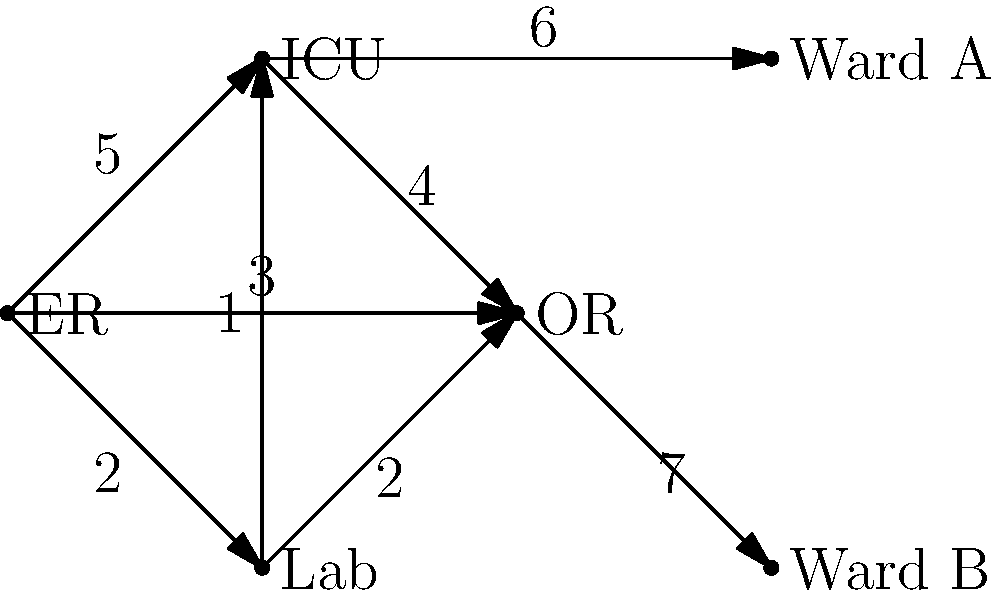Given the hospital department connectivity graph, where edge weights represent the time (in minutes) for staff to move between departments, what is the minimum spanning tree (MST) weight that ensures optimal connectivity while minimizing total travel time? To find the minimum spanning tree (MST) weight, we'll use Kruskal's algorithm:

1. Sort edges by weight in ascending order:
   Lab-ICU (1), ER-Lab (2), Lab-OR (2), ER-OR (3), ICU-OR (4), ER-ICU (5), ICU-Ward A (6), OR-Ward B (7)

2. Add edges to the MST, avoiding cycles:
   a) Lab-ICU (1): Add (weight 1)
   b) ER-Lab (2): Add (weight 3)
   c) Lab-OR (2): Add (weight 5)
   d) ER-OR (3): Skip (creates cycle)
   e) ICU-OR (4): Skip (creates cycle)
   f) ER-ICU (5): Skip (creates cycle)
   g) ICU-Ward A (6): Add (weight 11)
   h) OR-Ward B (7): Add (weight 18)

3. The MST is complete with 5 edges connecting all 6 vertices.

The total weight of the MST is the sum of the selected edge weights: 1 + 2 + 2 + 6 + 7 = 18.

This MST ensures optimal connectivity between all departments while minimizing the total travel time for staff.
Answer: 18 minutes 